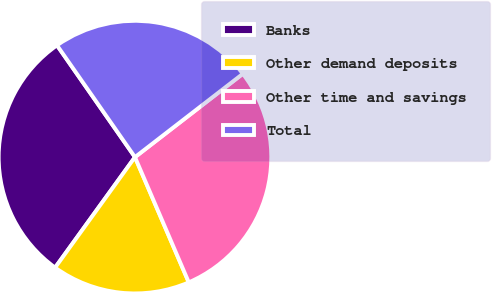Convert chart. <chart><loc_0><loc_0><loc_500><loc_500><pie_chart><fcel>Banks<fcel>Other demand deposits<fcel>Other time and savings<fcel>Total<nl><fcel>30.35%<fcel>16.42%<fcel>29.01%<fcel>24.22%<nl></chart> 